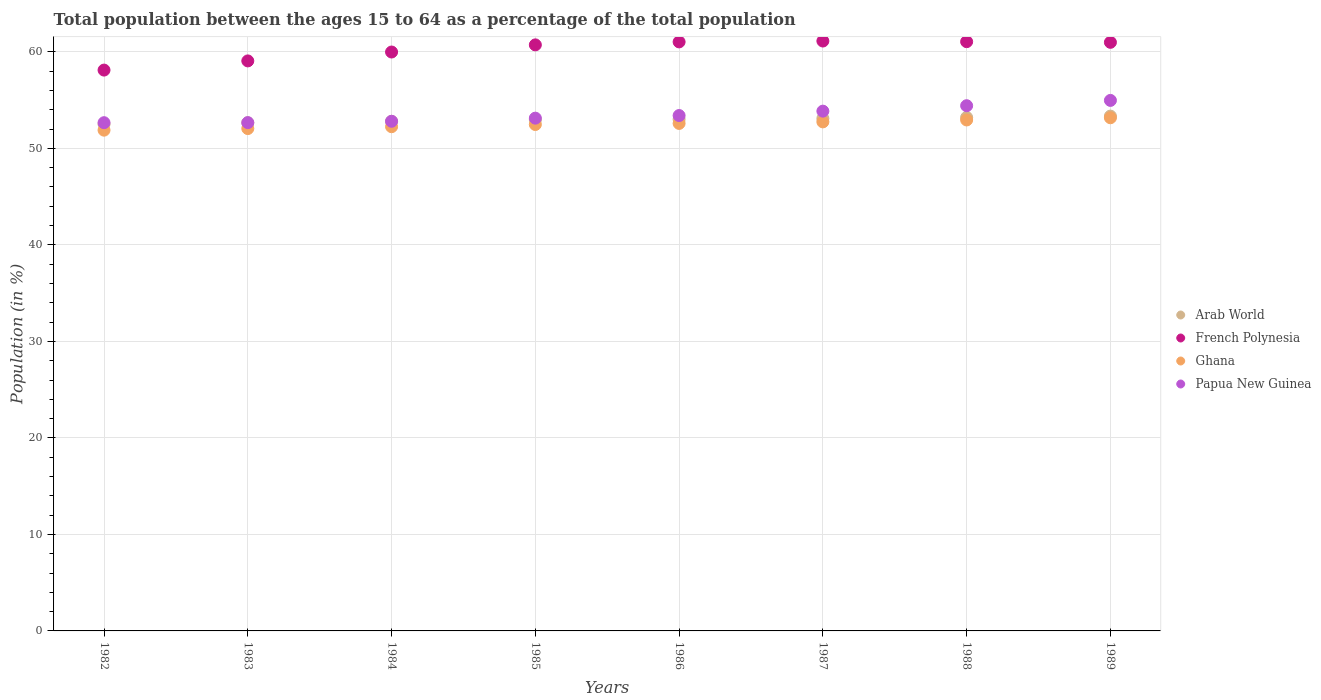Is the number of dotlines equal to the number of legend labels?
Make the answer very short. Yes. What is the percentage of the population ages 15 to 64 in Ghana in 1985?
Ensure brevity in your answer.  52.47. Across all years, what is the maximum percentage of the population ages 15 to 64 in Ghana?
Ensure brevity in your answer.  53.17. Across all years, what is the minimum percentage of the population ages 15 to 64 in French Polynesia?
Your response must be concise. 58.11. In which year was the percentage of the population ages 15 to 64 in Arab World maximum?
Ensure brevity in your answer.  1989. What is the total percentage of the population ages 15 to 64 in Ghana in the graph?
Ensure brevity in your answer.  420.12. What is the difference between the percentage of the population ages 15 to 64 in Arab World in 1982 and that in 1989?
Offer a very short reply. -0.83. What is the difference between the percentage of the population ages 15 to 64 in French Polynesia in 1984 and the percentage of the population ages 15 to 64 in Arab World in 1987?
Ensure brevity in your answer.  6.89. What is the average percentage of the population ages 15 to 64 in Arab World per year?
Your answer should be very brief. 52.95. In the year 1983, what is the difference between the percentage of the population ages 15 to 64 in French Polynesia and percentage of the population ages 15 to 64 in Arab World?
Your response must be concise. 6.41. In how many years, is the percentage of the population ages 15 to 64 in Papua New Guinea greater than 20?
Your answer should be very brief. 8. What is the ratio of the percentage of the population ages 15 to 64 in Papua New Guinea in 1988 to that in 1989?
Your response must be concise. 0.99. What is the difference between the highest and the second highest percentage of the population ages 15 to 64 in Arab World?
Give a very brief answer. 0.14. What is the difference between the highest and the lowest percentage of the population ages 15 to 64 in Ghana?
Provide a short and direct response. 1.29. Is the sum of the percentage of the population ages 15 to 64 in French Polynesia in 1983 and 1989 greater than the maximum percentage of the population ages 15 to 64 in Ghana across all years?
Make the answer very short. Yes. Is it the case that in every year, the sum of the percentage of the population ages 15 to 64 in French Polynesia and percentage of the population ages 15 to 64 in Ghana  is greater than the sum of percentage of the population ages 15 to 64 in Papua New Guinea and percentage of the population ages 15 to 64 in Arab World?
Your answer should be very brief. Yes. Is the percentage of the population ages 15 to 64 in Papua New Guinea strictly less than the percentage of the population ages 15 to 64 in French Polynesia over the years?
Provide a succinct answer. Yes. How many years are there in the graph?
Your answer should be compact. 8. What is the difference between two consecutive major ticks on the Y-axis?
Make the answer very short. 10. Where does the legend appear in the graph?
Offer a terse response. Center right. How many legend labels are there?
Provide a short and direct response. 4. What is the title of the graph?
Keep it short and to the point. Total population between the ages 15 to 64 as a percentage of the total population. Does "Mauritius" appear as one of the legend labels in the graph?
Keep it short and to the point. No. What is the label or title of the X-axis?
Offer a very short reply. Years. What is the label or title of the Y-axis?
Your response must be concise. Population (in %). What is the Population (in %) in Arab World in 1982?
Make the answer very short. 52.52. What is the Population (in %) in French Polynesia in 1982?
Make the answer very short. 58.11. What is the Population (in %) in Ghana in 1982?
Your answer should be very brief. 51.89. What is the Population (in %) in Papua New Guinea in 1982?
Make the answer very short. 52.66. What is the Population (in %) of Arab World in 1983?
Provide a short and direct response. 52.65. What is the Population (in %) in French Polynesia in 1983?
Give a very brief answer. 59.07. What is the Population (in %) of Ghana in 1983?
Give a very brief answer. 52.05. What is the Population (in %) of Papua New Guinea in 1983?
Give a very brief answer. 52.67. What is the Population (in %) in Arab World in 1984?
Provide a short and direct response. 52.8. What is the Population (in %) of French Polynesia in 1984?
Give a very brief answer. 59.99. What is the Population (in %) of Ghana in 1984?
Offer a terse response. 52.25. What is the Population (in %) of Papua New Guinea in 1984?
Ensure brevity in your answer.  52.81. What is the Population (in %) of Arab World in 1985?
Ensure brevity in your answer.  52.96. What is the Population (in %) of French Polynesia in 1985?
Offer a very short reply. 60.73. What is the Population (in %) in Ghana in 1985?
Offer a very short reply. 52.47. What is the Population (in %) of Papua New Guinea in 1985?
Make the answer very short. 53.13. What is the Population (in %) of Arab World in 1986?
Your answer should be compact. 53.02. What is the Population (in %) of French Polynesia in 1986?
Offer a very short reply. 61.04. What is the Population (in %) in Ghana in 1986?
Your response must be concise. 52.59. What is the Population (in %) in Papua New Guinea in 1986?
Your response must be concise. 53.4. What is the Population (in %) of Arab World in 1987?
Offer a very short reply. 53.1. What is the Population (in %) in French Polynesia in 1987?
Provide a succinct answer. 61.13. What is the Population (in %) in Ghana in 1987?
Your answer should be very brief. 52.75. What is the Population (in %) of Papua New Guinea in 1987?
Keep it short and to the point. 53.86. What is the Population (in %) in Arab World in 1988?
Your answer should be very brief. 53.21. What is the Population (in %) in French Polynesia in 1988?
Provide a succinct answer. 61.06. What is the Population (in %) of Ghana in 1988?
Offer a terse response. 52.95. What is the Population (in %) of Papua New Guinea in 1988?
Provide a short and direct response. 54.42. What is the Population (in %) of Arab World in 1989?
Provide a short and direct response. 53.35. What is the Population (in %) of French Polynesia in 1989?
Give a very brief answer. 60.99. What is the Population (in %) of Ghana in 1989?
Keep it short and to the point. 53.17. What is the Population (in %) of Papua New Guinea in 1989?
Keep it short and to the point. 54.97. Across all years, what is the maximum Population (in %) of Arab World?
Offer a terse response. 53.35. Across all years, what is the maximum Population (in %) of French Polynesia?
Provide a succinct answer. 61.13. Across all years, what is the maximum Population (in %) of Ghana?
Keep it short and to the point. 53.17. Across all years, what is the maximum Population (in %) in Papua New Guinea?
Make the answer very short. 54.97. Across all years, what is the minimum Population (in %) of Arab World?
Offer a very short reply. 52.52. Across all years, what is the minimum Population (in %) in French Polynesia?
Provide a succinct answer. 58.11. Across all years, what is the minimum Population (in %) of Ghana?
Offer a terse response. 51.89. Across all years, what is the minimum Population (in %) in Papua New Guinea?
Make the answer very short. 52.66. What is the total Population (in %) in Arab World in the graph?
Offer a very short reply. 423.6. What is the total Population (in %) of French Polynesia in the graph?
Offer a terse response. 482.11. What is the total Population (in %) of Ghana in the graph?
Provide a short and direct response. 420.12. What is the total Population (in %) in Papua New Guinea in the graph?
Make the answer very short. 427.94. What is the difference between the Population (in %) in Arab World in 1982 and that in 1983?
Give a very brief answer. -0.14. What is the difference between the Population (in %) in French Polynesia in 1982 and that in 1983?
Your answer should be very brief. -0.95. What is the difference between the Population (in %) in Ghana in 1982 and that in 1983?
Your response must be concise. -0.17. What is the difference between the Population (in %) of Papua New Guinea in 1982 and that in 1983?
Provide a succinct answer. -0.01. What is the difference between the Population (in %) in Arab World in 1982 and that in 1984?
Provide a succinct answer. -0.29. What is the difference between the Population (in %) in French Polynesia in 1982 and that in 1984?
Your answer should be compact. -1.87. What is the difference between the Population (in %) in Ghana in 1982 and that in 1984?
Your answer should be compact. -0.36. What is the difference between the Population (in %) of Papua New Guinea in 1982 and that in 1984?
Your answer should be compact. -0.15. What is the difference between the Population (in %) of Arab World in 1982 and that in 1985?
Keep it short and to the point. -0.44. What is the difference between the Population (in %) of French Polynesia in 1982 and that in 1985?
Your response must be concise. -2.61. What is the difference between the Population (in %) of Ghana in 1982 and that in 1985?
Your response must be concise. -0.59. What is the difference between the Population (in %) of Papua New Guinea in 1982 and that in 1985?
Offer a terse response. -0.47. What is the difference between the Population (in %) in Arab World in 1982 and that in 1986?
Provide a short and direct response. -0.5. What is the difference between the Population (in %) of French Polynesia in 1982 and that in 1986?
Offer a terse response. -2.92. What is the difference between the Population (in %) in Ghana in 1982 and that in 1986?
Provide a succinct answer. -0.7. What is the difference between the Population (in %) of Papua New Guinea in 1982 and that in 1986?
Your answer should be very brief. -0.74. What is the difference between the Population (in %) in Arab World in 1982 and that in 1987?
Keep it short and to the point. -0.58. What is the difference between the Population (in %) in French Polynesia in 1982 and that in 1987?
Make the answer very short. -3.01. What is the difference between the Population (in %) in Ghana in 1982 and that in 1987?
Offer a very short reply. -0.86. What is the difference between the Population (in %) in Papua New Guinea in 1982 and that in 1987?
Provide a succinct answer. -1.2. What is the difference between the Population (in %) in Arab World in 1982 and that in 1988?
Keep it short and to the point. -0.69. What is the difference between the Population (in %) of French Polynesia in 1982 and that in 1988?
Provide a succinct answer. -2.94. What is the difference between the Population (in %) in Ghana in 1982 and that in 1988?
Ensure brevity in your answer.  -1.06. What is the difference between the Population (in %) of Papua New Guinea in 1982 and that in 1988?
Your answer should be compact. -1.76. What is the difference between the Population (in %) of Arab World in 1982 and that in 1989?
Ensure brevity in your answer.  -0.83. What is the difference between the Population (in %) in French Polynesia in 1982 and that in 1989?
Offer a terse response. -2.88. What is the difference between the Population (in %) of Ghana in 1982 and that in 1989?
Offer a very short reply. -1.29. What is the difference between the Population (in %) of Papua New Guinea in 1982 and that in 1989?
Offer a terse response. -2.31. What is the difference between the Population (in %) of Arab World in 1983 and that in 1984?
Your answer should be very brief. -0.15. What is the difference between the Population (in %) in French Polynesia in 1983 and that in 1984?
Your answer should be compact. -0.92. What is the difference between the Population (in %) in Ghana in 1983 and that in 1984?
Offer a very short reply. -0.19. What is the difference between the Population (in %) of Papua New Guinea in 1983 and that in 1984?
Provide a succinct answer. -0.14. What is the difference between the Population (in %) in Arab World in 1983 and that in 1985?
Provide a succinct answer. -0.31. What is the difference between the Population (in %) of French Polynesia in 1983 and that in 1985?
Make the answer very short. -1.66. What is the difference between the Population (in %) in Ghana in 1983 and that in 1985?
Your answer should be compact. -0.42. What is the difference between the Population (in %) of Papua New Guinea in 1983 and that in 1985?
Your response must be concise. -0.46. What is the difference between the Population (in %) in Arab World in 1983 and that in 1986?
Offer a terse response. -0.36. What is the difference between the Population (in %) of French Polynesia in 1983 and that in 1986?
Your response must be concise. -1.97. What is the difference between the Population (in %) of Ghana in 1983 and that in 1986?
Your answer should be compact. -0.53. What is the difference between the Population (in %) in Papua New Guinea in 1983 and that in 1986?
Give a very brief answer. -0.73. What is the difference between the Population (in %) in Arab World in 1983 and that in 1987?
Provide a short and direct response. -0.45. What is the difference between the Population (in %) in French Polynesia in 1983 and that in 1987?
Give a very brief answer. -2.06. What is the difference between the Population (in %) in Ghana in 1983 and that in 1987?
Make the answer very short. -0.69. What is the difference between the Population (in %) of Papua New Guinea in 1983 and that in 1987?
Offer a terse response. -1.19. What is the difference between the Population (in %) of Arab World in 1983 and that in 1988?
Your response must be concise. -0.56. What is the difference between the Population (in %) of French Polynesia in 1983 and that in 1988?
Your answer should be compact. -1.99. What is the difference between the Population (in %) of Ghana in 1983 and that in 1988?
Offer a very short reply. -0.89. What is the difference between the Population (in %) of Papua New Guinea in 1983 and that in 1988?
Provide a short and direct response. -1.75. What is the difference between the Population (in %) in Arab World in 1983 and that in 1989?
Give a very brief answer. -0.69. What is the difference between the Population (in %) of French Polynesia in 1983 and that in 1989?
Make the answer very short. -1.93. What is the difference between the Population (in %) of Ghana in 1983 and that in 1989?
Your answer should be compact. -1.12. What is the difference between the Population (in %) of Papua New Guinea in 1983 and that in 1989?
Your answer should be compact. -2.3. What is the difference between the Population (in %) of Arab World in 1984 and that in 1985?
Your response must be concise. -0.16. What is the difference between the Population (in %) in French Polynesia in 1984 and that in 1985?
Make the answer very short. -0.74. What is the difference between the Population (in %) in Ghana in 1984 and that in 1985?
Make the answer very short. -0.23. What is the difference between the Population (in %) in Papua New Guinea in 1984 and that in 1985?
Your response must be concise. -0.32. What is the difference between the Population (in %) in Arab World in 1984 and that in 1986?
Keep it short and to the point. -0.21. What is the difference between the Population (in %) of French Polynesia in 1984 and that in 1986?
Make the answer very short. -1.05. What is the difference between the Population (in %) in Ghana in 1984 and that in 1986?
Offer a terse response. -0.34. What is the difference between the Population (in %) in Papua New Guinea in 1984 and that in 1986?
Offer a very short reply. -0.59. What is the difference between the Population (in %) of Arab World in 1984 and that in 1987?
Your answer should be compact. -0.3. What is the difference between the Population (in %) of French Polynesia in 1984 and that in 1987?
Provide a succinct answer. -1.14. What is the difference between the Population (in %) of Ghana in 1984 and that in 1987?
Give a very brief answer. -0.5. What is the difference between the Population (in %) in Papua New Guinea in 1984 and that in 1987?
Keep it short and to the point. -1.05. What is the difference between the Population (in %) of Arab World in 1984 and that in 1988?
Your response must be concise. -0.41. What is the difference between the Population (in %) of French Polynesia in 1984 and that in 1988?
Provide a short and direct response. -1.07. What is the difference between the Population (in %) of Ghana in 1984 and that in 1988?
Offer a terse response. -0.7. What is the difference between the Population (in %) in Papua New Guinea in 1984 and that in 1988?
Offer a terse response. -1.61. What is the difference between the Population (in %) in Arab World in 1984 and that in 1989?
Your answer should be very brief. -0.54. What is the difference between the Population (in %) of French Polynesia in 1984 and that in 1989?
Provide a succinct answer. -1. What is the difference between the Population (in %) in Ghana in 1984 and that in 1989?
Your response must be concise. -0.93. What is the difference between the Population (in %) of Papua New Guinea in 1984 and that in 1989?
Provide a short and direct response. -2.16. What is the difference between the Population (in %) of Arab World in 1985 and that in 1986?
Your answer should be compact. -0.06. What is the difference between the Population (in %) of French Polynesia in 1985 and that in 1986?
Ensure brevity in your answer.  -0.31. What is the difference between the Population (in %) in Ghana in 1985 and that in 1986?
Ensure brevity in your answer.  -0.11. What is the difference between the Population (in %) of Papua New Guinea in 1985 and that in 1986?
Offer a very short reply. -0.27. What is the difference between the Population (in %) in Arab World in 1985 and that in 1987?
Provide a short and direct response. -0.14. What is the difference between the Population (in %) of French Polynesia in 1985 and that in 1987?
Keep it short and to the point. -0.4. What is the difference between the Population (in %) of Ghana in 1985 and that in 1987?
Your answer should be compact. -0.27. What is the difference between the Population (in %) in Papua New Guinea in 1985 and that in 1987?
Give a very brief answer. -0.73. What is the difference between the Population (in %) in Arab World in 1985 and that in 1988?
Provide a succinct answer. -0.25. What is the difference between the Population (in %) in French Polynesia in 1985 and that in 1988?
Ensure brevity in your answer.  -0.33. What is the difference between the Population (in %) of Ghana in 1985 and that in 1988?
Ensure brevity in your answer.  -0.47. What is the difference between the Population (in %) of Papua New Guinea in 1985 and that in 1988?
Your answer should be very brief. -1.29. What is the difference between the Population (in %) of Arab World in 1985 and that in 1989?
Ensure brevity in your answer.  -0.39. What is the difference between the Population (in %) in French Polynesia in 1985 and that in 1989?
Your answer should be compact. -0.26. What is the difference between the Population (in %) in Ghana in 1985 and that in 1989?
Your response must be concise. -0.7. What is the difference between the Population (in %) in Papua New Guinea in 1985 and that in 1989?
Offer a very short reply. -1.84. What is the difference between the Population (in %) in Arab World in 1986 and that in 1987?
Your response must be concise. -0.09. What is the difference between the Population (in %) in French Polynesia in 1986 and that in 1987?
Give a very brief answer. -0.09. What is the difference between the Population (in %) of Ghana in 1986 and that in 1987?
Make the answer very short. -0.16. What is the difference between the Population (in %) in Papua New Guinea in 1986 and that in 1987?
Your answer should be compact. -0.46. What is the difference between the Population (in %) of Arab World in 1986 and that in 1988?
Your response must be concise. -0.19. What is the difference between the Population (in %) in French Polynesia in 1986 and that in 1988?
Ensure brevity in your answer.  -0.02. What is the difference between the Population (in %) in Ghana in 1986 and that in 1988?
Offer a very short reply. -0.36. What is the difference between the Population (in %) in Papua New Guinea in 1986 and that in 1988?
Ensure brevity in your answer.  -1.02. What is the difference between the Population (in %) in Arab World in 1986 and that in 1989?
Keep it short and to the point. -0.33. What is the difference between the Population (in %) in French Polynesia in 1986 and that in 1989?
Offer a terse response. 0.04. What is the difference between the Population (in %) in Ghana in 1986 and that in 1989?
Ensure brevity in your answer.  -0.59. What is the difference between the Population (in %) of Papua New Guinea in 1986 and that in 1989?
Your answer should be very brief. -1.57. What is the difference between the Population (in %) of Arab World in 1987 and that in 1988?
Provide a succinct answer. -0.11. What is the difference between the Population (in %) in French Polynesia in 1987 and that in 1988?
Offer a very short reply. 0.07. What is the difference between the Population (in %) of Ghana in 1987 and that in 1988?
Your answer should be compact. -0.2. What is the difference between the Population (in %) in Papua New Guinea in 1987 and that in 1988?
Make the answer very short. -0.56. What is the difference between the Population (in %) in Arab World in 1987 and that in 1989?
Your response must be concise. -0.25. What is the difference between the Population (in %) of French Polynesia in 1987 and that in 1989?
Provide a short and direct response. 0.13. What is the difference between the Population (in %) of Ghana in 1987 and that in 1989?
Your answer should be very brief. -0.43. What is the difference between the Population (in %) of Papua New Guinea in 1987 and that in 1989?
Give a very brief answer. -1.11. What is the difference between the Population (in %) of Arab World in 1988 and that in 1989?
Offer a terse response. -0.14. What is the difference between the Population (in %) in French Polynesia in 1988 and that in 1989?
Provide a short and direct response. 0.07. What is the difference between the Population (in %) in Ghana in 1988 and that in 1989?
Your answer should be very brief. -0.23. What is the difference between the Population (in %) of Papua New Guinea in 1988 and that in 1989?
Offer a terse response. -0.55. What is the difference between the Population (in %) of Arab World in 1982 and the Population (in %) of French Polynesia in 1983?
Make the answer very short. -6.55. What is the difference between the Population (in %) of Arab World in 1982 and the Population (in %) of Ghana in 1983?
Your answer should be very brief. 0.46. What is the difference between the Population (in %) in Arab World in 1982 and the Population (in %) in Papua New Guinea in 1983?
Provide a succinct answer. -0.15. What is the difference between the Population (in %) of French Polynesia in 1982 and the Population (in %) of Ghana in 1983?
Make the answer very short. 6.06. What is the difference between the Population (in %) of French Polynesia in 1982 and the Population (in %) of Papua New Guinea in 1983?
Your answer should be very brief. 5.44. What is the difference between the Population (in %) of Ghana in 1982 and the Population (in %) of Papua New Guinea in 1983?
Ensure brevity in your answer.  -0.78. What is the difference between the Population (in %) in Arab World in 1982 and the Population (in %) in French Polynesia in 1984?
Your response must be concise. -7.47. What is the difference between the Population (in %) of Arab World in 1982 and the Population (in %) of Ghana in 1984?
Offer a terse response. 0.27. What is the difference between the Population (in %) of Arab World in 1982 and the Population (in %) of Papua New Guinea in 1984?
Your answer should be very brief. -0.29. What is the difference between the Population (in %) of French Polynesia in 1982 and the Population (in %) of Ghana in 1984?
Offer a very short reply. 5.87. What is the difference between the Population (in %) of French Polynesia in 1982 and the Population (in %) of Papua New Guinea in 1984?
Keep it short and to the point. 5.3. What is the difference between the Population (in %) of Ghana in 1982 and the Population (in %) of Papua New Guinea in 1984?
Give a very brief answer. -0.92. What is the difference between the Population (in %) in Arab World in 1982 and the Population (in %) in French Polynesia in 1985?
Your answer should be compact. -8.21. What is the difference between the Population (in %) in Arab World in 1982 and the Population (in %) in Ghana in 1985?
Give a very brief answer. 0.04. What is the difference between the Population (in %) in Arab World in 1982 and the Population (in %) in Papua New Guinea in 1985?
Offer a terse response. -0.62. What is the difference between the Population (in %) of French Polynesia in 1982 and the Population (in %) of Ghana in 1985?
Offer a very short reply. 5.64. What is the difference between the Population (in %) in French Polynesia in 1982 and the Population (in %) in Papua New Guinea in 1985?
Your response must be concise. 4.98. What is the difference between the Population (in %) in Ghana in 1982 and the Population (in %) in Papua New Guinea in 1985?
Ensure brevity in your answer.  -1.24. What is the difference between the Population (in %) of Arab World in 1982 and the Population (in %) of French Polynesia in 1986?
Make the answer very short. -8.52. What is the difference between the Population (in %) in Arab World in 1982 and the Population (in %) in Ghana in 1986?
Provide a short and direct response. -0.07. What is the difference between the Population (in %) in Arab World in 1982 and the Population (in %) in Papua New Guinea in 1986?
Your response must be concise. -0.89. What is the difference between the Population (in %) in French Polynesia in 1982 and the Population (in %) in Ghana in 1986?
Keep it short and to the point. 5.53. What is the difference between the Population (in %) in French Polynesia in 1982 and the Population (in %) in Papua New Guinea in 1986?
Your answer should be compact. 4.71. What is the difference between the Population (in %) in Ghana in 1982 and the Population (in %) in Papua New Guinea in 1986?
Your answer should be very brief. -1.52. What is the difference between the Population (in %) of Arab World in 1982 and the Population (in %) of French Polynesia in 1987?
Offer a very short reply. -8.61. What is the difference between the Population (in %) in Arab World in 1982 and the Population (in %) in Ghana in 1987?
Provide a succinct answer. -0.23. What is the difference between the Population (in %) in Arab World in 1982 and the Population (in %) in Papua New Guinea in 1987?
Keep it short and to the point. -1.34. What is the difference between the Population (in %) in French Polynesia in 1982 and the Population (in %) in Ghana in 1987?
Keep it short and to the point. 5.37. What is the difference between the Population (in %) of French Polynesia in 1982 and the Population (in %) of Papua New Guinea in 1987?
Make the answer very short. 4.25. What is the difference between the Population (in %) of Ghana in 1982 and the Population (in %) of Papua New Guinea in 1987?
Your response must be concise. -1.97. What is the difference between the Population (in %) of Arab World in 1982 and the Population (in %) of French Polynesia in 1988?
Offer a terse response. -8.54. What is the difference between the Population (in %) of Arab World in 1982 and the Population (in %) of Ghana in 1988?
Your answer should be compact. -0.43. What is the difference between the Population (in %) in Arab World in 1982 and the Population (in %) in Papua New Guinea in 1988?
Offer a very short reply. -1.91. What is the difference between the Population (in %) of French Polynesia in 1982 and the Population (in %) of Ghana in 1988?
Your answer should be compact. 5.17. What is the difference between the Population (in %) in French Polynesia in 1982 and the Population (in %) in Papua New Guinea in 1988?
Your response must be concise. 3.69. What is the difference between the Population (in %) of Ghana in 1982 and the Population (in %) of Papua New Guinea in 1988?
Offer a terse response. -2.53. What is the difference between the Population (in %) in Arab World in 1982 and the Population (in %) in French Polynesia in 1989?
Provide a succinct answer. -8.48. What is the difference between the Population (in %) in Arab World in 1982 and the Population (in %) in Ghana in 1989?
Ensure brevity in your answer.  -0.66. What is the difference between the Population (in %) in Arab World in 1982 and the Population (in %) in Papua New Guinea in 1989?
Ensure brevity in your answer.  -2.46. What is the difference between the Population (in %) in French Polynesia in 1982 and the Population (in %) in Ghana in 1989?
Ensure brevity in your answer.  4.94. What is the difference between the Population (in %) in French Polynesia in 1982 and the Population (in %) in Papua New Guinea in 1989?
Give a very brief answer. 3.14. What is the difference between the Population (in %) in Ghana in 1982 and the Population (in %) in Papua New Guinea in 1989?
Your answer should be compact. -3.08. What is the difference between the Population (in %) in Arab World in 1983 and the Population (in %) in French Polynesia in 1984?
Make the answer very short. -7.33. What is the difference between the Population (in %) in Arab World in 1983 and the Population (in %) in Ghana in 1984?
Make the answer very short. 0.41. What is the difference between the Population (in %) in Arab World in 1983 and the Population (in %) in Papua New Guinea in 1984?
Offer a very short reply. -0.16. What is the difference between the Population (in %) in French Polynesia in 1983 and the Population (in %) in Ghana in 1984?
Keep it short and to the point. 6.82. What is the difference between the Population (in %) of French Polynesia in 1983 and the Population (in %) of Papua New Guinea in 1984?
Offer a terse response. 6.26. What is the difference between the Population (in %) in Ghana in 1983 and the Population (in %) in Papua New Guinea in 1984?
Provide a short and direct response. -0.76. What is the difference between the Population (in %) of Arab World in 1983 and the Population (in %) of French Polynesia in 1985?
Keep it short and to the point. -8.08. What is the difference between the Population (in %) in Arab World in 1983 and the Population (in %) in Ghana in 1985?
Provide a short and direct response. 0.18. What is the difference between the Population (in %) of Arab World in 1983 and the Population (in %) of Papua New Guinea in 1985?
Ensure brevity in your answer.  -0.48. What is the difference between the Population (in %) in French Polynesia in 1983 and the Population (in %) in Ghana in 1985?
Your answer should be very brief. 6.59. What is the difference between the Population (in %) of French Polynesia in 1983 and the Population (in %) of Papua New Guinea in 1985?
Your response must be concise. 5.93. What is the difference between the Population (in %) of Ghana in 1983 and the Population (in %) of Papua New Guinea in 1985?
Make the answer very short. -1.08. What is the difference between the Population (in %) in Arab World in 1983 and the Population (in %) in French Polynesia in 1986?
Keep it short and to the point. -8.38. What is the difference between the Population (in %) in Arab World in 1983 and the Population (in %) in Ghana in 1986?
Ensure brevity in your answer.  0.06. What is the difference between the Population (in %) of Arab World in 1983 and the Population (in %) of Papua New Guinea in 1986?
Your answer should be compact. -0.75. What is the difference between the Population (in %) in French Polynesia in 1983 and the Population (in %) in Ghana in 1986?
Offer a very short reply. 6.48. What is the difference between the Population (in %) of French Polynesia in 1983 and the Population (in %) of Papua New Guinea in 1986?
Ensure brevity in your answer.  5.66. What is the difference between the Population (in %) in Ghana in 1983 and the Population (in %) in Papua New Guinea in 1986?
Provide a short and direct response. -1.35. What is the difference between the Population (in %) of Arab World in 1983 and the Population (in %) of French Polynesia in 1987?
Offer a very short reply. -8.47. What is the difference between the Population (in %) of Arab World in 1983 and the Population (in %) of Ghana in 1987?
Provide a succinct answer. -0.09. What is the difference between the Population (in %) in Arab World in 1983 and the Population (in %) in Papua New Guinea in 1987?
Provide a succinct answer. -1.21. What is the difference between the Population (in %) of French Polynesia in 1983 and the Population (in %) of Ghana in 1987?
Your answer should be compact. 6.32. What is the difference between the Population (in %) of French Polynesia in 1983 and the Population (in %) of Papua New Guinea in 1987?
Make the answer very short. 5.21. What is the difference between the Population (in %) in Ghana in 1983 and the Population (in %) in Papua New Guinea in 1987?
Your response must be concise. -1.81. What is the difference between the Population (in %) in Arab World in 1983 and the Population (in %) in French Polynesia in 1988?
Your answer should be compact. -8.41. What is the difference between the Population (in %) in Arab World in 1983 and the Population (in %) in Ghana in 1988?
Offer a terse response. -0.29. What is the difference between the Population (in %) of Arab World in 1983 and the Population (in %) of Papua New Guinea in 1988?
Ensure brevity in your answer.  -1.77. What is the difference between the Population (in %) of French Polynesia in 1983 and the Population (in %) of Ghana in 1988?
Your response must be concise. 6.12. What is the difference between the Population (in %) in French Polynesia in 1983 and the Population (in %) in Papua New Guinea in 1988?
Provide a short and direct response. 4.64. What is the difference between the Population (in %) of Ghana in 1983 and the Population (in %) of Papua New Guinea in 1988?
Offer a very short reply. -2.37. What is the difference between the Population (in %) in Arab World in 1983 and the Population (in %) in French Polynesia in 1989?
Your answer should be very brief. -8.34. What is the difference between the Population (in %) in Arab World in 1983 and the Population (in %) in Ghana in 1989?
Your response must be concise. -0.52. What is the difference between the Population (in %) in Arab World in 1983 and the Population (in %) in Papua New Guinea in 1989?
Give a very brief answer. -2.32. What is the difference between the Population (in %) of French Polynesia in 1983 and the Population (in %) of Ghana in 1989?
Ensure brevity in your answer.  5.89. What is the difference between the Population (in %) of French Polynesia in 1983 and the Population (in %) of Papua New Guinea in 1989?
Make the answer very short. 4.09. What is the difference between the Population (in %) in Ghana in 1983 and the Population (in %) in Papua New Guinea in 1989?
Make the answer very short. -2.92. What is the difference between the Population (in %) of Arab World in 1984 and the Population (in %) of French Polynesia in 1985?
Keep it short and to the point. -7.93. What is the difference between the Population (in %) of Arab World in 1984 and the Population (in %) of Ghana in 1985?
Provide a short and direct response. 0.33. What is the difference between the Population (in %) in Arab World in 1984 and the Population (in %) in Papua New Guinea in 1985?
Make the answer very short. -0.33. What is the difference between the Population (in %) of French Polynesia in 1984 and the Population (in %) of Ghana in 1985?
Provide a succinct answer. 7.51. What is the difference between the Population (in %) of French Polynesia in 1984 and the Population (in %) of Papua New Guinea in 1985?
Offer a very short reply. 6.85. What is the difference between the Population (in %) in Ghana in 1984 and the Population (in %) in Papua New Guinea in 1985?
Give a very brief answer. -0.89. What is the difference between the Population (in %) of Arab World in 1984 and the Population (in %) of French Polynesia in 1986?
Give a very brief answer. -8.23. What is the difference between the Population (in %) of Arab World in 1984 and the Population (in %) of Ghana in 1986?
Offer a terse response. 0.21. What is the difference between the Population (in %) in Arab World in 1984 and the Population (in %) in Papua New Guinea in 1986?
Make the answer very short. -0.6. What is the difference between the Population (in %) in French Polynesia in 1984 and the Population (in %) in Ghana in 1986?
Provide a short and direct response. 7.4. What is the difference between the Population (in %) of French Polynesia in 1984 and the Population (in %) of Papua New Guinea in 1986?
Give a very brief answer. 6.58. What is the difference between the Population (in %) in Ghana in 1984 and the Population (in %) in Papua New Guinea in 1986?
Your answer should be compact. -1.16. What is the difference between the Population (in %) of Arab World in 1984 and the Population (in %) of French Polynesia in 1987?
Offer a very short reply. -8.32. What is the difference between the Population (in %) of Arab World in 1984 and the Population (in %) of Ghana in 1987?
Your answer should be compact. 0.06. What is the difference between the Population (in %) in Arab World in 1984 and the Population (in %) in Papua New Guinea in 1987?
Give a very brief answer. -1.06. What is the difference between the Population (in %) in French Polynesia in 1984 and the Population (in %) in Ghana in 1987?
Offer a very short reply. 7.24. What is the difference between the Population (in %) of French Polynesia in 1984 and the Population (in %) of Papua New Guinea in 1987?
Make the answer very short. 6.13. What is the difference between the Population (in %) in Ghana in 1984 and the Population (in %) in Papua New Guinea in 1987?
Offer a terse response. -1.61. What is the difference between the Population (in %) in Arab World in 1984 and the Population (in %) in French Polynesia in 1988?
Your answer should be compact. -8.26. What is the difference between the Population (in %) in Arab World in 1984 and the Population (in %) in Ghana in 1988?
Your answer should be compact. -0.14. What is the difference between the Population (in %) of Arab World in 1984 and the Population (in %) of Papua New Guinea in 1988?
Make the answer very short. -1.62. What is the difference between the Population (in %) in French Polynesia in 1984 and the Population (in %) in Ghana in 1988?
Ensure brevity in your answer.  7.04. What is the difference between the Population (in %) of French Polynesia in 1984 and the Population (in %) of Papua New Guinea in 1988?
Your answer should be very brief. 5.56. What is the difference between the Population (in %) of Ghana in 1984 and the Population (in %) of Papua New Guinea in 1988?
Provide a short and direct response. -2.18. What is the difference between the Population (in %) in Arab World in 1984 and the Population (in %) in French Polynesia in 1989?
Your response must be concise. -8.19. What is the difference between the Population (in %) in Arab World in 1984 and the Population (in %) in Ghana in 1989?
Your answer should be compact. -0.37. What is the difference between the Population (in %) in Arab World in 1984 and the Population (in %) in Papua New Guinea in 1989?
Your answer should be very brief. -2.17. What is the difference between the Population (in %) in French Polynesia in 1984 and the Population (in %) in Ghana in 1989?
Ensure brevity in your answer.  6.81. What is the difference between the Population (in %) in French Polynesia in 1984 and the Population (in %) in Papua New Guinea in 1989?
Provide a succinct answer. 5.01. What is the difference between the Population (in %) in Ghana in 1984 and the Population (in %) in Papua New Guinea in 1989?
Provide a short and direct response. -2.73. What is the difference between the Population (in %) in Arab World in 1985 and the Population (in %) in French Polynesia in 1986?
Give a very brief answer. -8.08. What is the difference between the Population (in %) in Arab World in 1985 and the Population (in %) in Ghana in 1986?
Provide a short and direct response. 0.37. What is the difference between the Population (in %) of Arab World in 1985 and the Population (in %) of Papua New Guinea in 1986?
Give a very brief answer. -0.44. What is the difference between the Population (in %) in French Polynesia in 1985 and the Population (in %) in Ghana in 1986?
Your answer should be compact. 8.14. What is the difference between the Population (in %) in French Polynesia in 1985 and the Population (in %) in Papua New Guinea in 1986?
Your response must be concise. 7.32. What is the difference between the Population (in %) in Ghana in 1985 and the Population (in %) in Papua New Guinea in 1986?
Give a very brief answer. -0.93. What is the difference between the Population (in %) of Arab World in 1985 and the Population (in %) of French Polynesia in 1987?
Your answer should be compact. -8.17. What is the difference between the Population (in %) in Arab World in 1985 and the Population (in %) in Ghana in 1987?
Ensure brevity in your answer.  0.21. What is the difference between the Population (in %) in Arab World in 1985 and the Population (in %) in Papua New Guinea in 1987?
Your response must be concise. -0.9. What is the difference between the Population (in %) in French Polynesia in 1985 and the Population (in %) in Ghana in 1987?
Ensure brevity in your answer.  7.98. What is the difference between the Population (in %) of French Polynesia in 1985 and the Population (in %) of Papua New Guinea in 1987?
Keep it short and to the point. 6.87. What is the difference between the Population (in %) of Ghana in 1985 and the Population (in %) of Papua New Guinea in 1987?
Your response must be concise. -1.39. What is the difference between the Population (in %) in Arab World in 1985 and the Population (in %) in French Polynesia in 1988?
Give a very brief answer. -8.1. What is the difference between the Population (in %) of Arab World in 1985 and the Population (in %) of Ghana in 1988?
Your answer should be very brief. 0.01. What is the difference between the Population (in %) in Arab World in 1985 and the Population (in %) in Papua New Guinea in 1988?
Ensure brevity in your answer.  -1.46. What is the difference between the Population (in %) of French Polynesia in 1985 and the Population (in %) of Ghana in 1988?
Your answer should be compact. 7.78. What is the difference between the Population (in %) of French Polynesia in 1985 and the Population (in %) of Papua New Guinea in 1988?
Offer a very short reply. 6.3. What is the difference between the Population (in %) of Ghana in 1985 and the Population (in %) of Papua New Guinea in 1988?
Provide a short and direct response. -1.95. What is the difference between the Population (in %) of Arab World in 1985 and the Population (in %) of French Polynesia in 1989?
Offer a terse response. -8.03. What is the difference between the Population (in %) in Arab World in 1985 and the Population (in %) in Ghana in 1989?
Your answer should be compact. -0.21. What is the difference between the Population (in %) of Arab World in 1985 and the Population (in %) of Papua New Guinea in 1989?
Keep it short and to the point. -2.01. What is the difference between the Population (in %) of French Polynesia in 1985 and the Population (in %) of Ghana in 1989?
Provide a succinct answer. 7.55. What is the difference between the Population (in %) of French Polynesia in 1985 and the Population (in %) of Papua New Guinea in 1989?
Keep it short and to the point. 5.75. What is the difference between the Population (in %) in Ghana in 1985 and the Population (in %) in Papua New Guinea in 1989?
Make the answer very short. -2.5. What is the difference between the Population (in %) of Arab World in 1986 and the Population (in %) of French Polynesia in 1987?
Offer a very short reply. -8.11. What is the difference between the Population (in %) in Arab World in 1986 and the Population (in %) in Ghana in 1987?
Provide a succinct answer. 0.27. What is the difference between the Population (in %) of Arab World in 1986 and the Population (in %) of Papua New Guinea in 1987?
Provide a short and direct response. -0.84. What is the difference between the Population (in %) of French Polynesia in 1986 and the Population (in %) of Ghana in 1987?
Provide a succinct answer. 8.29. What is the difference between the Population (in %) of French Polynesia in 1986 and the Population (in %) of Papua New Guinea in 1987?
Your answer should be compact. 7.18. What is the difference between the Population (in %) of Ghana in 1986 and the Population (in %) of Papua New Guinea in 1987?
Provide a short and direct response. -1.27. What is the difference between the Population (in %) of Arab World in 1986 and the Population (in %) of French Polynesia in 1988?
Provide a succinct answer. -8.04. What is the difference between the Population (in %) of Arab World in 1986 and the Population (in %) of Ghana in 1988?
Provide a short and direct response. 0.07. What is the difference between the Population (in %) of Arab World in 1986 and the Population (in %) of Papua New Guinea in 1988?
Your response must be concise. -1.41. What is the difference between the Population (in %) of French Polynesia in 1986 and the Population (in %) of Ghana in 1988?
Your answer should be very brief. 8.09. What is the difference between the Population (in %) of French Polynesia in 1986 and the Population (in %) of Papua New Guinea in 1988?
Ensure brevity in your answer.  6.61. What is the difference between the Population (in %) in Ghana in 1986 and the Population (in %) in Papua New Guinea in 1988?
Your response must be concise. -1.84. What is the difference between the Population (in %) of Arab World in 1986 and the Population (in %) of French Polynesia in 1989?
Provide a succinct answer. -7.98. What is the difference between the Population (in %) in Arab World in 1986 and the Population (in %) in Ghana in 1989?
Your response must be concise. -0.16. What is the difference between the Population (in %) in Arab World in 1986 and the Population (in %) in Papua New Guinea in 1989?
Your response must be concise. -1.96. What is the difference between the Population (in %) in French Polynesia in 1986 and the Population (in %) in Ghana in 1989?
Provide a succinct answer. 7.86. What is the difference between the Population (in %) of French Polynesia in 1986 and the Population (in %) of Papua New Guinea in 1989?
Provide a succinct answer. 6.06. What is the difference between the Population (in %) of Ghana in 1986 and the Population (in %) of Papua New Guinea in 1989?
Offer a very short reply. -2.39. What is the difference between the Population (in %) of Arab World in 1987 and the Population (in %) of French Polynesia in 1988?
Offer a terse response. -7.96. What is the difference between the Population (in %) of Arab World in 1987 and the Population (in %) of Ghana in 1988?
Ensure brevity in your answer.  0.15. What is the difference between the Population (in %) in Arab World in 1987 and the Population (in %) in Papua New Guinea in 1988?
Your answer should be compact. -1.32. What is the difference between the Population (in %) of French Polynesia in 1987 and the Population (in %) of Ghana in 1988?
Your answer should be compact. 8.18. What is the difference between the Population (in %) of French Polynesia in 1987 and the Population (in %) of Papua New Guinea in 1988?
Your response must be concise. 6.7. What is the difference between the Population (in %) of Ghana in 1987 and the Population (in %) of Papua New Guinea in 1988?
Your answer should be very brief. -1.68. What is the difference between the Population (in %) of Arab World in 1987 and the Population (in %) of French Polynesia in 1989?
Ensure brevity in your answer.  -7.89. What is the difference between the Population (in %) in Arab World in 1987 and the Population (in %) in Ghana in 1989?
Make the answer very short. -0.07. What is the difference between the Population (in %) of Arab World in 1987 and the Population (in %) of Papua New Guinea in 1989?
Your answer should be very brief. -1.87. What is the difference between the Population (in %) in French Polynesia in 1987 and the Population (in %) in Ghana in 1989?
Make the answer very short. 7.95. What is the difference between the Population (in %) of French Polynesia in 1987 and the Population (in %) of Papua New Guinea in 1989?
Offer a very short reply. 6.15. What is the difference between the Population (in %) in Ghana in 1987 and the Population (in %) in Papua New Guinea in 1989?
Give a very brief answer. -2.23. What is the difference between the Population (in %) in Arab World in 1988 and the Population (in %) in French Polynesia in 1989?
Give a very brief answer. -7.78. What is the difference between the Population (in %) in Arab World in 1988 and the Population (in %) in Ghana in 1989?
Offer a terse response. 0.03. What is the difference between the Population (in %) of Arab World in 1988 and the Population (in %) of Papua New Guinea in 1989?
Make the answer very short. -1.76. What is the difference between the Population (in %) of French Polynesia in 1988 and the Population (in %) of Ghana in 1989?
Your answer should be compact. 7.88. What is the difference between the Population (in %) of French Polynesia in 1988 and the Population (in %) of Papua New Guinea in 1989?
Provide a short and direct response. 6.09. What is the difference between the Population (in %) of Ghana in 1988 and the Population (in %) of Papua New Guinea in 1989?
Offer a very short reply. -2.03. What is the average Population (in %) in Arab World per year?
Offer a terse response. 52.95. What is the average Population (in %) in French Polynesia per year?
Offer a very short reply. 60.26. What is the average Population (in %) of Ghana per year?
Your answer should be very brief. 52.52. What is the average Population (in %) in Papua New Guinea per year?
Give a very brief answer. 53.49. In the year 1982, what is the difference between the Population (in %) of Arab World and Population (in %) of French Polynesia?
Your answer should be compact. -5.6. In the year 1982, what is the difference between the Population (in %) in Arab World and Population (in %) in Ghana?
Keep it short and to the point. 0.63. In the year 1982, what is the difference between the Population (in %) of Arab World and Population (in %) of Papua New Guinea?
Offer a terse response. -0.15. In the year 1982, what is the difference between the Population (in %) in French Polynesia and Population (in %) in Ghana?
Ensure brevity in your answer.  6.23. In the year 1982, what is the difference between the Population (in %) in French Polynesia and Population (in %) in Papua New Guinea?
Make the answer very short. 5.45. In the year 1982, what is the difference between the Population (in %) of Ghana and Population (in %) of Papua New Guinea?
Keep it short and to the point. -0.77. In the year 1983, what is the difference between the Population (in %) of Arab World and Population (in %) of French Polynesia?
Keep it short and to the point. -6.41. In the year 1983, what is the difference between the Population (in %) in Arab World and Population (in %) in Ghana?
Ensure brevity in your answer.  0.6. In the year 1983, what is the difference between the Population (in %) in Arab World and Population (in %) in Papua New Guinea?
Ensure brevity in your answer.  -0.02. In the year 1983, what is the difference between the Population (in %) in French Polynesia and Population (in %) in Ghana?
Your answer should be very brief. 7.01. In the year 1983, what is the difference between the Population (in %) of French Polynesia and Population (in %) of Papua New Guinea?
Provide a succinct answer. 6.4. In the year 1983, what is the difference between the Population (in %) in Ghana and Population (in %) in Papua New Guinea?
Make the answer very short. -0.62. In the year 1984, what is the difference between the Population (in %) of Arab World and Population (in %) of French Polynesia?
Make the answer very short. -7.18. In the year 1984, what is the difference between the Population (in %) of Arab World and Population (in %) of Ghana?
Your answer should be compact. 0.56. In the year 1984, what is the difference between the Population (in %) in Arab World and Population (in %) in Papua New Guinea?
Your response must be concise. -0.01. In the year 1984, what is the difference between the Population (in %) of French Polynesia and Population (in %) of Ghana?
Provide a succinct answer. 7.74. In the year 1984, what is the difference between the Population (in %) of French Polynesia and Population (in %) of Papua New Guinea?
Your answer should be compact. 7.18. In the year 1984, what is the difference between the Population (in %) in Ghana and Population (in %) in Papua New Guinea?
Provide a succinct answer. -0.56. In the year 1985, what is the difference between the Population (in %) in Arab World and Population (in %) in French Polynesia?
Provide a short and direct response. -7.77. In the year 1985, what is the difference between the Population (in %) in Arab World and Population (in %) in Ghana?
Ensure brevity in your answer.  0.49. In the year 1985, what is the difference between the Population (in %) of Arab World and Population (in %) of Papua New Guinea?
Your answer should be compact. -0.17. In the year 1985, what is the difference between the Population (in %) in French Polynesia and Population (in %) in Ghana?
Your answer should be very brief. 8.25. In the year 1985, what is the difference between the Population (in %) in French Polynesia and Population (in %) in Papua New Guinea?
Offer a terse response. 7.59. In the year 1985, what is the difference between the Population (in %) of Ghana and Population (in %) of Papua New Guinea?
Offer a terse response. -0.66. In the year 1986, what is the difference between the Population (in %) in Arab World and Population (in %) in French Polynesia?
Keep it short and to the point. -8.02. In the year 1986, what is the difference between the Population (in %) of Arab World and Population (in %) of Ghana?
Ensure brevity in your answer.  0.43. In the year 1986, what is the difference between the Population (in %) in Arab World and Population (in %) in Papua New Guinea?
Make the answer very short. -0.39. In the year 1986, what is the difference between the Population (in %) in French Polynesia and Population (in %) in Ghana?
Keep it short and to the point. 8.45. In the year 1986, what is the difference between the Population (in %) in French Polynesia and Population (in %) in Papua New Guinea?
Give a very brief answer. 7.63. In the year 1986, what is the difference between the Population (in %) of Ghana and Population (in %) of Papua New Guinea?
Provide a short and direct response. -0.82. In the year 1987, what is the difference between the Population (in %) in Arab World and Population (in %) in French Polynesia?
Your response must be concise. -8.02. In the year 1987, what is the difference between the Population (in %) in Arab World and Population (in %) in Ghana?
Offer a terse response. 0.35. In the year 1987, what is the difference between the Population (in %) of Arab World and Population (in %) of Papua New Guinea?
Ensure brevity in your answer.  -0.76. In the year 1987, what is the difference between the Population (in %) of French Polynesia and Population (in %) of Ghana?
Ensure brevity in your answer.  8.38. In the year 1987, what is the difference between the Population (in %) of French Polynesia and Population (in %) of Papua New Guinea?
Provide a succinct answer. 7.27. In the year 1987, what is the difference between the Population (in %) in Ghana and Population (in %) in Papua New Guinea?
Make the answer very short. -1.11. In the year 1988, what is the difference between the Population (in %) in Arab World and Population (in %) in French Polynesia?
Provide a short and direct response. -7.85. In the year 1988, what is the difference between the Population (in %) in Arab World and Population (in %) in Ghana?
Keep it short and to the point. 0.26. In the year 1988, what is the difference between the Population (in %) of Arab World and Population (in %) of Papua New Guinea?
Provide a succinct answer. -1.21. In the year 1988, what is the difference between the Population (in %) in French Polynesia and Population (in %) in Ghana?
Make the answer very short. 8.11. In the year 1988, what is the difference between the Population (in %) in French Polynesia and Population (in %) in Papua New Guinea?
Keep it short and to the point. 6.64. In the year 1988, what is the difference between the Population (in %) in Ghana and Population (in %) in Papua New Guinea?
Keep it short and to the point. -1.48. In the year 1989, what is the difference between the Population (in %) in Arab World and Population (in %) in French Polynesia?
Give a very brief answer. -7.64. In the year 1989, what is the difference between the Population (in %) in Arab World and Population (in %) in Ghana?
Keep it short and to the point. 0.17. In the year 1989, what is the difference between the Population (in %) in Arab World and Population (in %) in Papua New Guinea?
Your response must be concise. -1.63. In the year 1989, what is the difference between the Population (in %) in French Polynesia and Population (in %) in Ghana?
Give a very brief answer. 7.82. In the year 1989, what is the difference between the Population (in %) in French Polynesia and Population (in %) in Papua New Guinea?
Provide a succinct answer. 6.02. In the year 1989, what is the difference between the Population (in %) of Ghana and Population (in %) of Papua New Guinea?
Ensure brevity in your answer.  -1.8. What is the ratio of the Population (in %) of Arab World in 1982 to that in 1983?
Your response must be concise. 1. What is the ratio of the Population (in %) of French Polynesia in 1982 to that in 1983?
Provide a succinct answer. 0.98. What is the ratio of the Population (in %) of Papua New Guinea in 1982 to that in 1983?
Ensure brevity in your answer.  1. What is the ratio of the Population (in %) in French Polynesia in 1982 to that in 1984?
Give a very brief answer. 0.97. What is the ratio of the Population (in %) of Ghana in 1982 to that in 1984?
Give a very brief answer. 0.99. What is the ratio of the Population (in %) of Papua New Guinea in 1982 to that in 1984?
Your answer should be very brief. 1. What is the ratio of the Population (in %) of French Polynesia in 1982 to that in 1985?
Your response must be concise. 0.96. What is the ratio of the Population (in %) of Arab World in 1982 to that in 1986?
Give a very brief answer. 0.99. What is the ratio of the Population (in %) in French Polynesia in 1982 to that in 1986?
Provide a succinct answer. 0.95. What is the ratio of the Population (in %) of Ghana in 1982 to that in 1986?
Ensure brevity in your answer.  0.99. What is the ratio of the Population (in %) in Papua New Guinea in 1982 to that in 1986?
Make the answer very short. 0.99. What is the ratio of the Population (in %) in French Polynesia in 1982 to that in 1987?
Make the answer very short. 0.95. What is the ratio of the Population (in %) in Ghana in 1982 to that in 1987?
Keep it short and to the point. 0.98. What is the ratio of the Population (in %) in Papua New Guinea in 1982 to that in 1987?
Your answer should be compact. 0.98. What is the ratio of the Population (in %) of Arab World in 1982 to that in 1988?
Keep it short and to the point. 0.99. What is the ratio of the Population (in %) in French Polynesia in 1982 to that in 1988?
Provide a succinct answer. 0.95. What is the ratio of the Population (in %) in Papua New Guinea in 1982 to that in 1988?
Offer a very short reply. 0.97. What is the ratio of the Population (in %) in Arab World in 1982 to that in 1989?
Give a very brief answer. 0.98. What is the ratio of the Population (in %) of French Polynesia in 1982 to that in 1989?
Your response must be concise. 0.95. What is the ratio of the Population (in %) in Ghana in 1982 to that in 1989?
Your answer should be very brief. 0.98. What is the ratio of the Population (in %) of Papua New Guinea in 1982 to that in 1989?
Offer a very short reply. 0.96. What is the ratio of the Population (in %) in Arab World in 1983 to that in 1984?
Make the answer very short. 1. What is the ratio of the Population (in %) of French Polynesia in 1983 to that in 1984?
Offer a terse response. 0.98. What is the ratio of the Population (in %) of Papua New Guinea in 1983 to that in 1984?
Provide a succinct answer. 1. What is the ratio of the Population (in %) in Arab World in 1983 to that in 1985?
Your answer should be very brief. 0.99. What is the ratio of the Population (in %) in French Polynesia in 1983 to that in 1985?
Your response must be concise. 0.97. What is the ratio of the Population (in %) in Ghana in 1983 to that in 1985?
Ensure brevity in your answer.  0.99. What is the ratio of the Population (in %) of Papua New Guinea in 1983 to that in 1985?
Provide a short and direct response. 0.99. What is the ratio of the Population (in %) in French Polynesia in 1983 to that in 1986?
Your answer should be compact. 0.97. What is the ratio of the Population (in %) in Papua New Guinea in 1983 to that in 1986?
Provide a short and direct response. 0.99. What is the ratio of the Population (in %) in Arab World in 1983 to that in 1987?
Offer a very short reply. 0.99. What is the ratio of the Population (in %) of French Polynesia in 1983 to that in 1987?
Your answer should be very brief. 0.97. What is the ratio of the Population (in %) in Ghana in 1983 to that in 1987?
Offer a very short reply. 0.99. What is the ratio of the Population (in %) of Papua New Guinea in 1983 to that in 1987?
Make the answer very short. 0.98. What is the ratio of the Population (in %) of French Polynesia in 1983 to that in 1988?
Your response must be concise. 0.97. What is the ratio of the Population (in %) of Ghana in 1983 to that in 1988?
Give a very brief answer. 0.98. What is the ratio of the Population (in %) in Papua New Guinea in 1983 to that in 1988?
Ensure brevity in your answer.  0.97. What is the ratio of the Population (in %) of Arab World in 1983 to that in 1989?
Your response must be concise. 0.99. What is the ratio of the Population (in %) in French Polynesia in 1983 to that in 1989?
Offer a very short reply. 0.97. What is the ratio of the Population (in %) in Ghana in 1983 to that in 1989?
Offer a very short reply. 0.98. What is the ratio of the Population (in %) of Papua New Guinea in 1983 to that in 1989?
Provide a succinct answer. 0.96. What is the ratio of the Population (in %) in Arab World in 1984 to that in 1985?
Keep it short and to the point. 1. What is the ratio of the Population (in %) of Papua New Guinea in 1984 to that in 1985?
Make the answer very short. 0.99. What is the ratio of the Population (in %) of French Polynesia in 1984 to that in 1986?
Keep it short and to the point. 0.98. What is the ratio of the Population (in %) of Ghana in 1984 to that in 1986?
Provide a short and direct response. 0.99. What is the ratio of the Population (in %) in Papua New Guinea in 1984 to that in 1986?
Provide a short and direct response. 0.99. What is the ratio of the Population (in %) in French Polynesia in 1984 to that in 1987?
Your answer should be compact. 0.98. What is the ratio of the Population (in %) of Papua New Guinea in 1984 to that in 1987?
Provide a short and direct response. 0.98. What is the ratio of the Population (in %) in Arab World in 1984 to that in 1988?
Your answer should be compact. 0.99. What is the ratio of the Population (in %) in French Polynesia in 1984 to that in 1988?
Offer a very short reply. 0.98. What is the ratio of the Population (in %) in Ghana in 1984 to that in 1988?
Your answer should be compact. 0.99. What is the ratio of the Population (in %) in Papua New Guinea in 1984 to that in 1988?
Your answer should be very brief. 0.97. What is the ratio of the Population (in %) in French Polynesia in 1984 to that in 1989?
Provide a short and direct response. 0.98. What is the ratio of the Population (in %) of Ghana in 1984 to that in 1989?
Keep it short and to the point. 0.98. What is the ratio of the Population (in %) in Papua New Guinea in 1984 to that in 1989?
Offer a terse response. 0.96. What is the ratio of the Population (in %) of Arab World in 1985 to that in 1986?
Provide a succinct answer. 1. What is the ratio of the Population (in %) in Papua New Guinea in 1985 to that in 1986?
Offer a very short reply. 0.99. What is the ratio of the Population (in %) in French Polynesia in 1985 to that in 1987?
Offer a very short reply. 0.99. What is the ratio of the Population (in %) in Ghana in 1985 to that in 1987?
Your response must be concise. 0.99. What is the ratio of the Population (in %) of Papua New Guinea in 1985 to that in 1987?
Provide a short and direct response. 0.99. What is the ratio of the Population (in %) of French Polynesia in 1985 to that in 1988?
Provide a succinct answer. 0.99. What is the ratio of the Population (in %) of Ghana in 1985 to that in 1988?
Your response must be concise. 0.99. What is the ratio of the Population (in %) of Papua New Guinea in 1985 to that in 1988?
Offer a terse response. 0.98. What is the ratio of the Population (in %) in Arab World in 1985 to that in 1989?
Your answer should be compact. 0.99. What is the ratio of the Population (in %) of French Polynesia in 1985 to that in 1989?
Your response must be concise. 1. What is the ratio of the Population (in %) in Papua New Guinea in 1985 to that in 1989?
Keep it short and to the point. 0.97. What is the ratio of the Population (in %) of Arab World in 1986 to that in 1987?
Make the answer very short. 1. What is the ratio of the Population (in %) in French Polynesia in 1986 to that in 1987?
Provide a short and direct response. 1. What is the ratio of the Population (in %) of Arab World in 1986 to that in 1988?
Give a very brief answer. 1. What is the ratio of the Population (in %) of French Polynesia in 1986 to that in 1988?
Make the answer very short. 1. What is the ratio of the Population (in %) of Ghana in 1986 to that in 1988?
Your answer should be very brief. 0.99. What is the ratio of the Population (in %) in Papua New Guinea in 1986 to that in 1988?
Keep it short and to the point. 0.98. What is the ratio of the Population (in %) in Arab World in 1986 to that in 1989?
Make the answer very short. 0.99. What is the ratio of the Population (in %) in Ghana in 1986 to that in 1989?
Keep it short and to the point. 0.99. What is the ratio of the Population (in %) in Papua New Guinea in 1986 to that in 1989?
Make the answer very short. 0.97. What is the ratio of the Population (in %) in French Polynesia in 1987 to that in 1988?
Make the answer very short. 1. What is the ratio of the Population (in %) in Arab World in 1987 to that in 1989?
Give a very brief answer. 1. What is the ratio of the Population (in %) of French Polynesia in 1987 to that in 1989?
Ensure brevity in your answer.  1. What is the ratio of the Population (in %) in Ghana in 1987 to that in 1989?
Make the answer very short. 0.99. What is the ratio of the Population (in %) in Papua New Guinea in 1987 to that in 1989?
Your response must be concise. 0.98. What is the ratio of the Population (in %) of Arab World in 1988 to that in 1989?
Give a very brief answer. 1. What is the ratio of the Population (in %) of French Polynesia in 1988 to that in 1989?
Make the answer very short. 1. What is the ratio of the Population (in %) in Ghana in 1988 to that in 1989?
Offer a very short reply. 1. What is the ratio of the Population (in %) in Papua New Guinea in 1988 to that in 1989?
Give a very brief answer. 0.99. What is the difference between the highest and the second highest Population (in %) in Arab World?
Your answer should be compact. 0.14. What is the difference between the highest and the second highest Population (in %) in French Polynesia?
Your response must be concise. 0.07. What is the difference between the highest and the second highest Population (in %) of Ghana?
Ensure brevity in your answer.  0.23. What is the difference between the highest and the second highest Population (in %) in Papua New Guinea?
Ensure brevity in your answer.  0.55. What is the difference between the highest and the lowest Population (in %) in Arab World?
Your answer should be compact. 0.83. What is the difference between the highest and the lowest Population (in %) in French Polynesia?
Provide a succinct answer. 3.01. What is the difference between the highest and the lowest Population (in %) in Ghana?
Provide a succinct answer. 1.29. What is the difference between the highest and the lowest Population (in %) of Papua New Guinea?
Your answer should be compact. 2.31. 